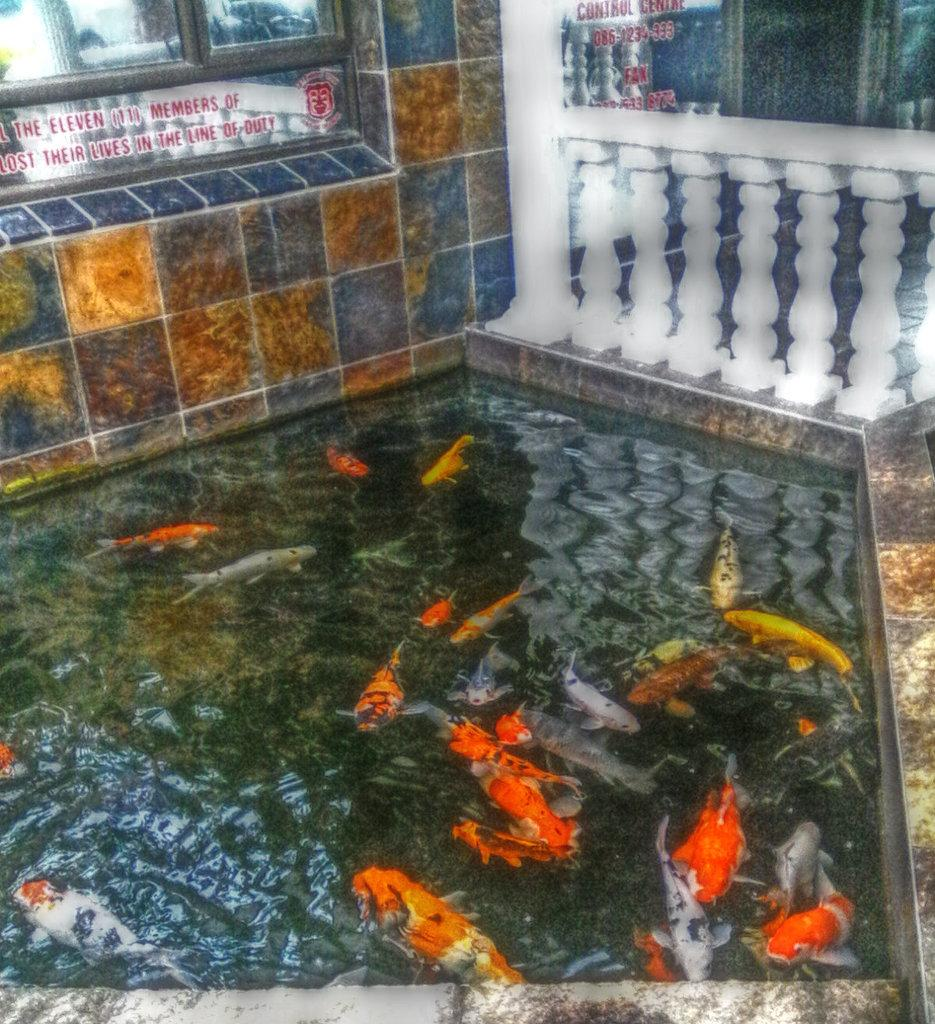What can be seen swimming in the water in the image? There are fishes in the water in the image. What architectural feature is visible in the background of the image? There is a railing in the background of the image. What is written or displayed on a window in the background of the image? There is text visible on a window in the background of the image. What type of structure is present in the background of the image? There is a wall in the background of the image. What color is the pear that is being worn by the fish in the image? There is no pear or any fruit present in the image; it features fishes in the water and various background elements. 